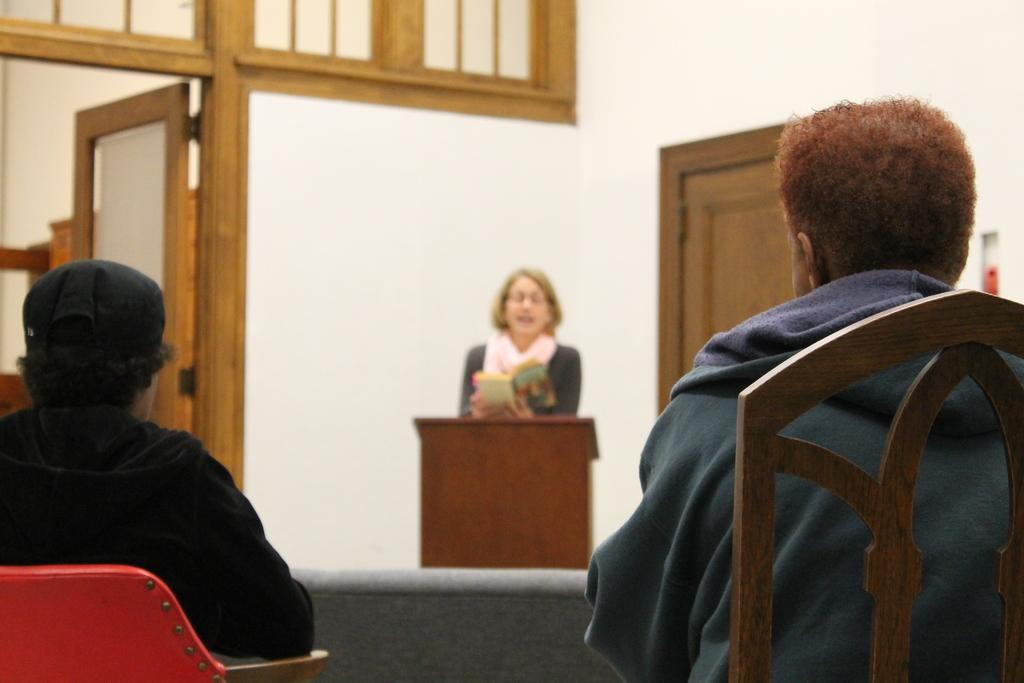How many people are sitting in the image? There are two persons sitting on chairs in the image. What can be seen behind the sitting persons? There is a podium in the image. What is the person behind the podium doing? The person standing behind the podium is reading a book. What is visible in the background of the image? There is a wall and a door visible in the background. Can you see any signs in the image? There are no signs visible in the image. Is there a horse present in the image? There is no horse present in the image. 